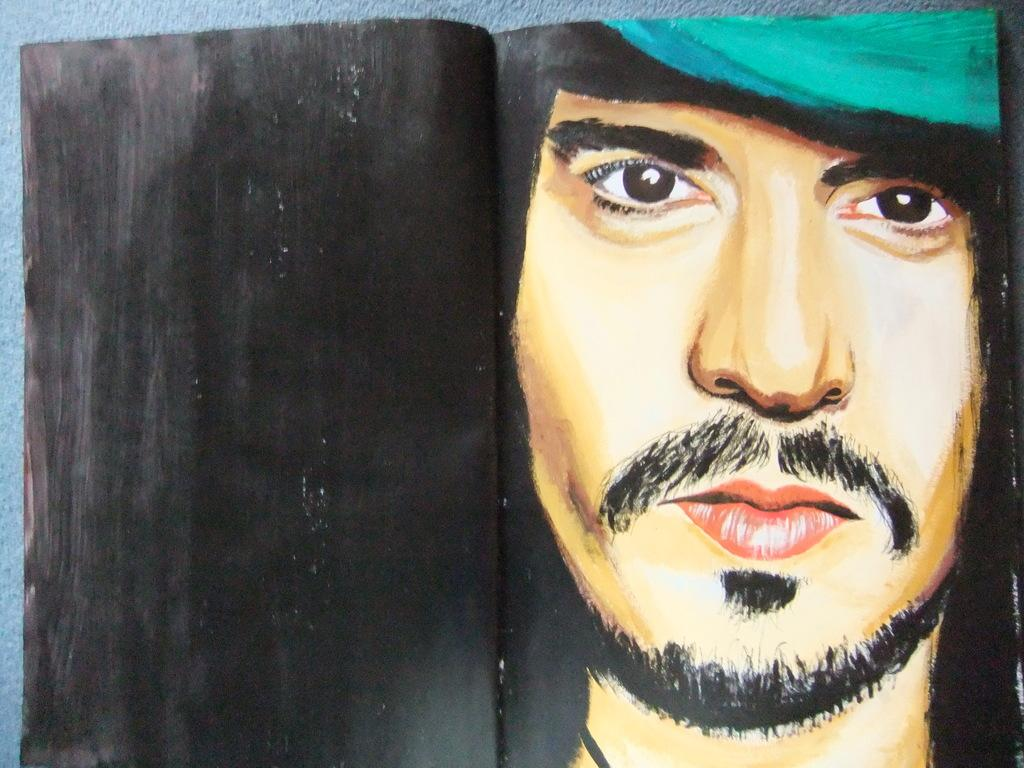What is the main subject of the image? There is a painting in the image. What does the painting depict? The painting depicts a person's face. On what surface is the painting placed? The painting is on a surface. How many bubbles are floating around the person's face in the painting? There are no bubbles present in the painting; it depicts a person's face without any bubbles. 